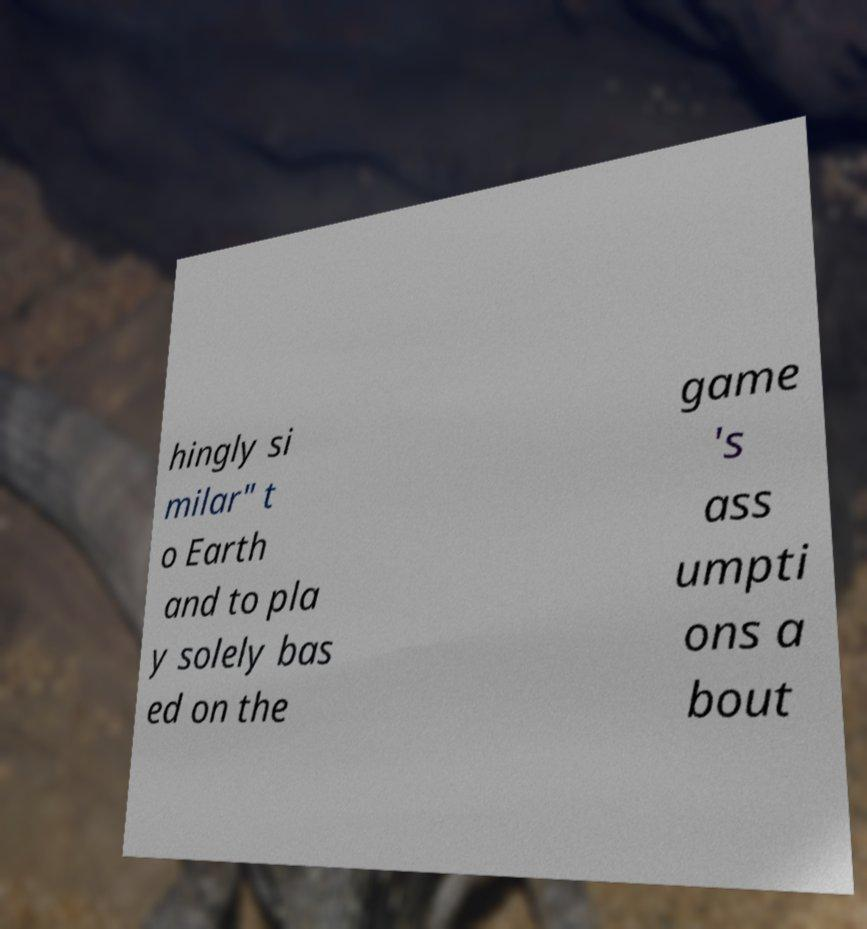There's text embedded in this image that I need extracted. Can you transcribe it verbatim? hingly si milar" t o Earth and to pla y solely bas ed on the game 's ass umpti ons a bout 